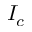Convert formula to latex. <formula><loc_0><loc_0><loc_500><loc_500>I _ { c }</formula> 